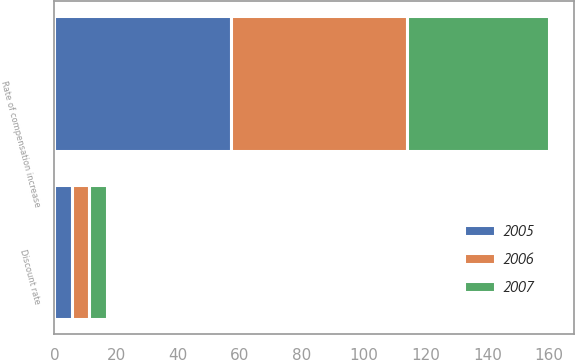<chart> <loc_0><loc_0><loc_500><loc_500><stacked_bar_chart><ecel><fcel>Discount rate<fcel>Rate of compensation increase<nl><fcel>2007<fcel>5.75<fcel>46<nl><fcel>2006<fcel>5.5<fcel>57<nl><fcel>2005<fcel>5.75<fcel>57<nl></chart> 